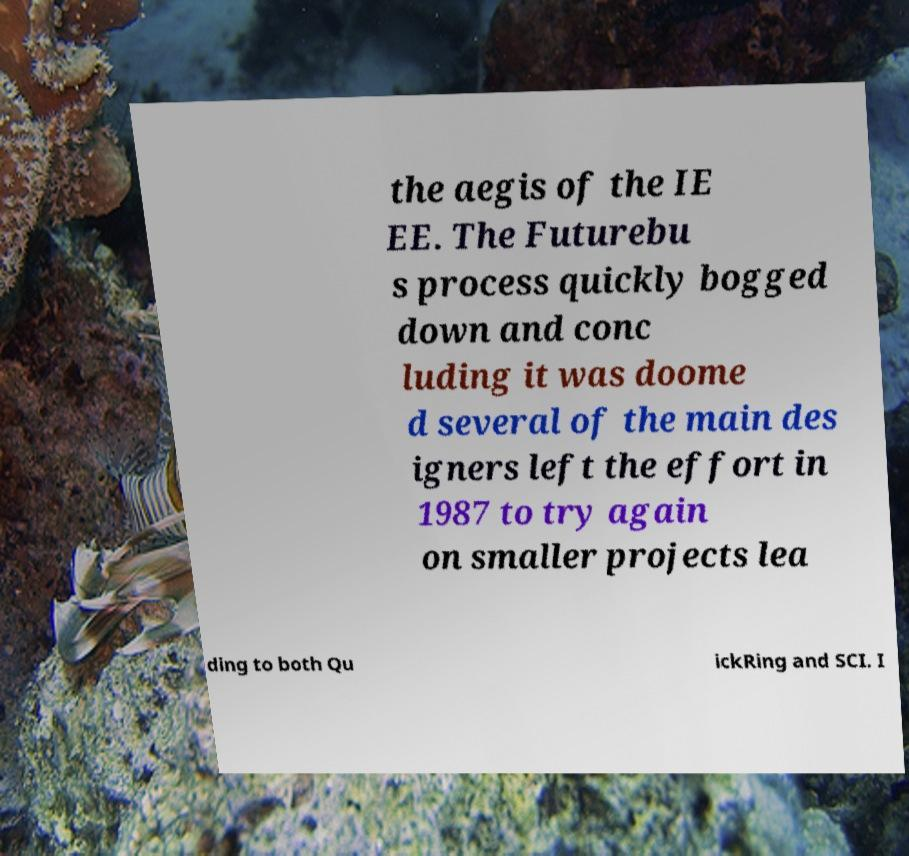For documentation purposes, I need the text within this image transcribed. Could you provide that? the aegis of the IE EE. The Futurebu s process quickly bogged down and conc luding it was doome d several of the main des igners left the effort in 1987 to try again on smaller projects lea ding to both Qu ickRing and SCI. I 